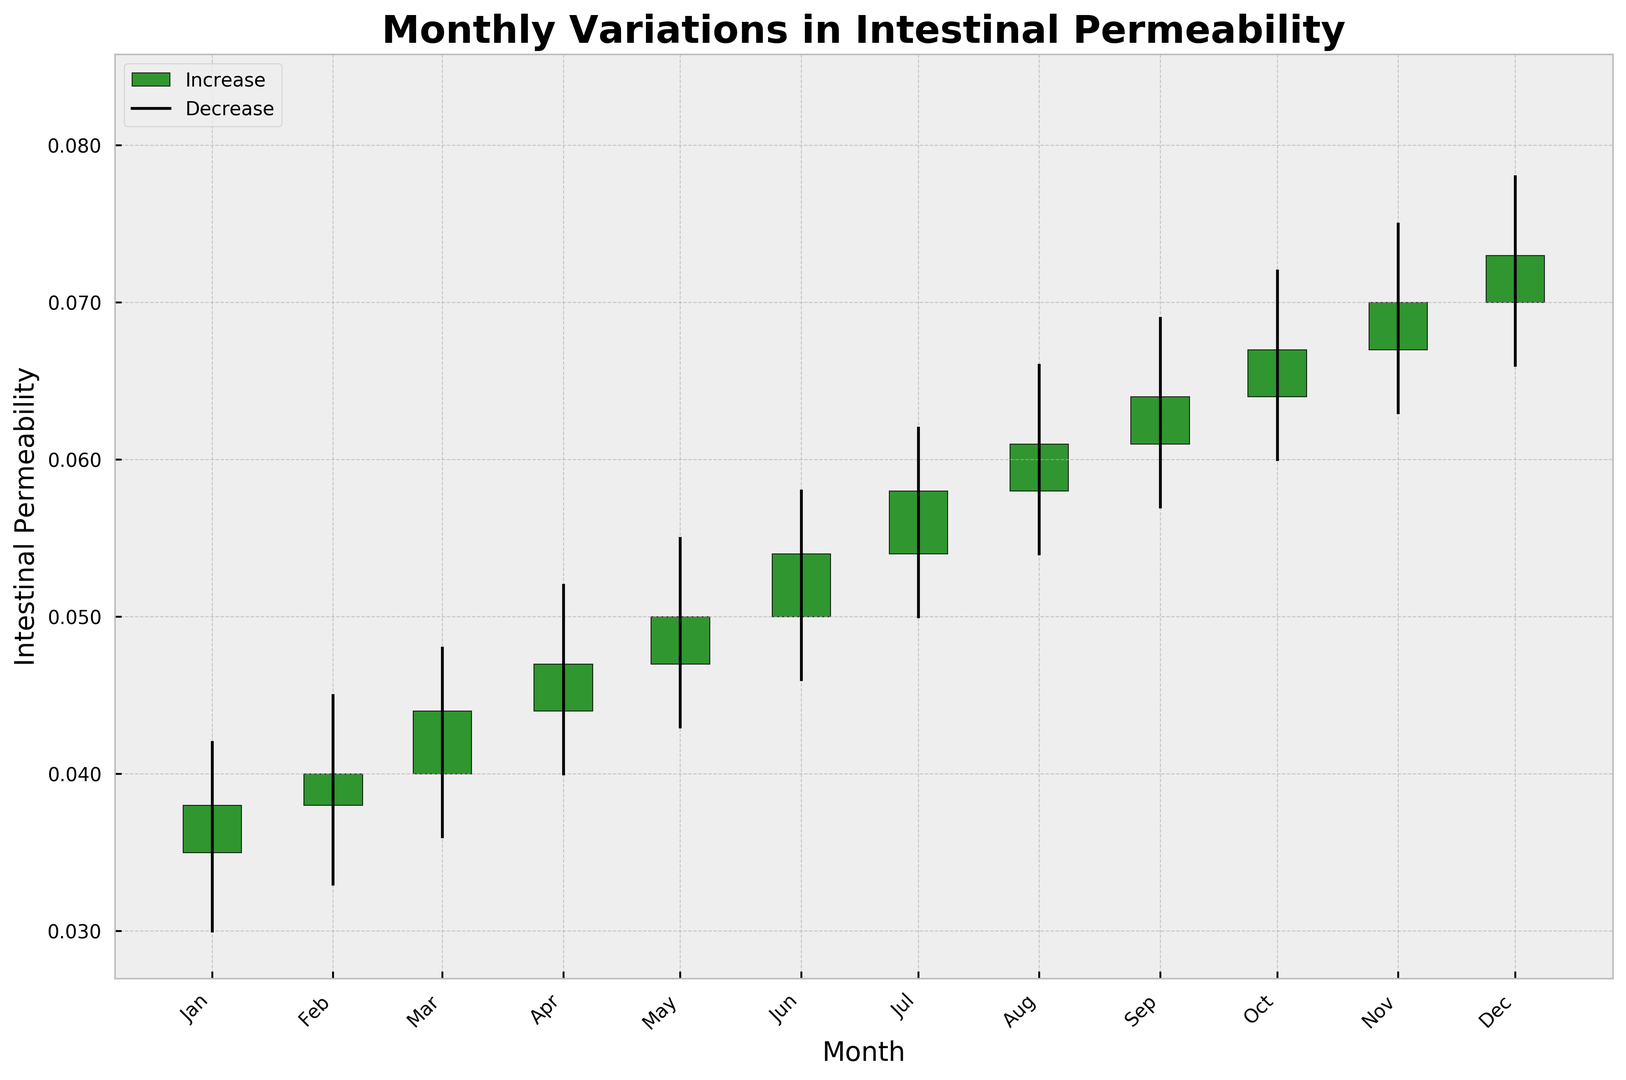What month shows the highest value for intestinal permeability? By looking at the chart, we can identify the month with the highest "High" value. The highest point on the y-axis corresponding to a candlestick is in December, where the "High" value is 0.078.
Answer: December Which month had the largest increase in permeability from opening to closing value? To determine this, we need to check the difference between the "Close" and "Open" values for each month. August shows the largest increase, with "Close" at 0.061 and "Open" at 0.058, resulting in a difference of 0.003.
Answer: August How does the trend look from January to December? Does the permeability generally increase or decrease? We can observe the general trend by looking at the "Close" values from January to December. The "Close" values consistently increase from 0.038 in January to 0.073 in December, indicating an overall increase in intestinal permeability.
Answer: Increase In which months did the permeability decrease from opening to closing value? To find this answer, we need to identify months where the "Close" value is less than the "Open" value. There are no such months; all months show an increase.
Answer: None What is the average of the closing values for the first six months? To find this, add the closing values from January to June (0.038 + 0.040 + 0.044 + 0.047 + 0.050 + 0.054) and divide by 6. The total sum is 0.273, and the average is 0.273 / 6 = 0.0455.
Answer: 0.0455 Which month has the smallest range in intestinal permeability? The range for each month is calculated by subtracting the "Low" value from the "High" value. January has the smallest range, with "High" at 0.042 and "Low" at 0.030, resulting in a range of 0.012.
Answer: January What is the difference in the "High" value between the highest month and the lowest month? The highest "High" value is in December at 0.078, and the lowest "High" value is in January at 0.042. The difference is 0.078 - 0.042 = 0.036.
Answer: 0.036 